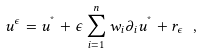<formula> <loc_0><loc_0><loc_500><loc_500>u ^ { \epsilon } = u ^ { ^ { * } } + \epsilon \sum _ { i = 1 } ^ { n } w _ { i } \partial _ { i } u ^ { ^ { * } } + r _ { \epsilon } \ ,</formula> 